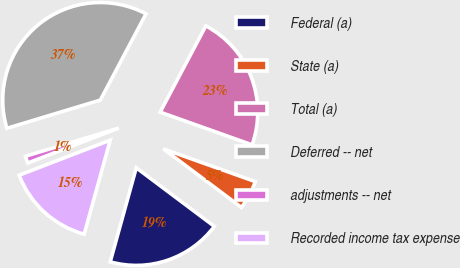<chart> <loc_0><loc_0><loc_500><loc_500><pie_chart><fcel>Federal (a)<fcel>State (a)<fcel>Total (a)<fcel>Deferred -- net<fcel>adjustments -- net<fcel>Recorded income tax expense<nl><fcel>19.06%<fcel>4.8%<fcel>22.69%<fcel>37.42%<fcel>1.18%<fcel>14.85%<nl></chart> 